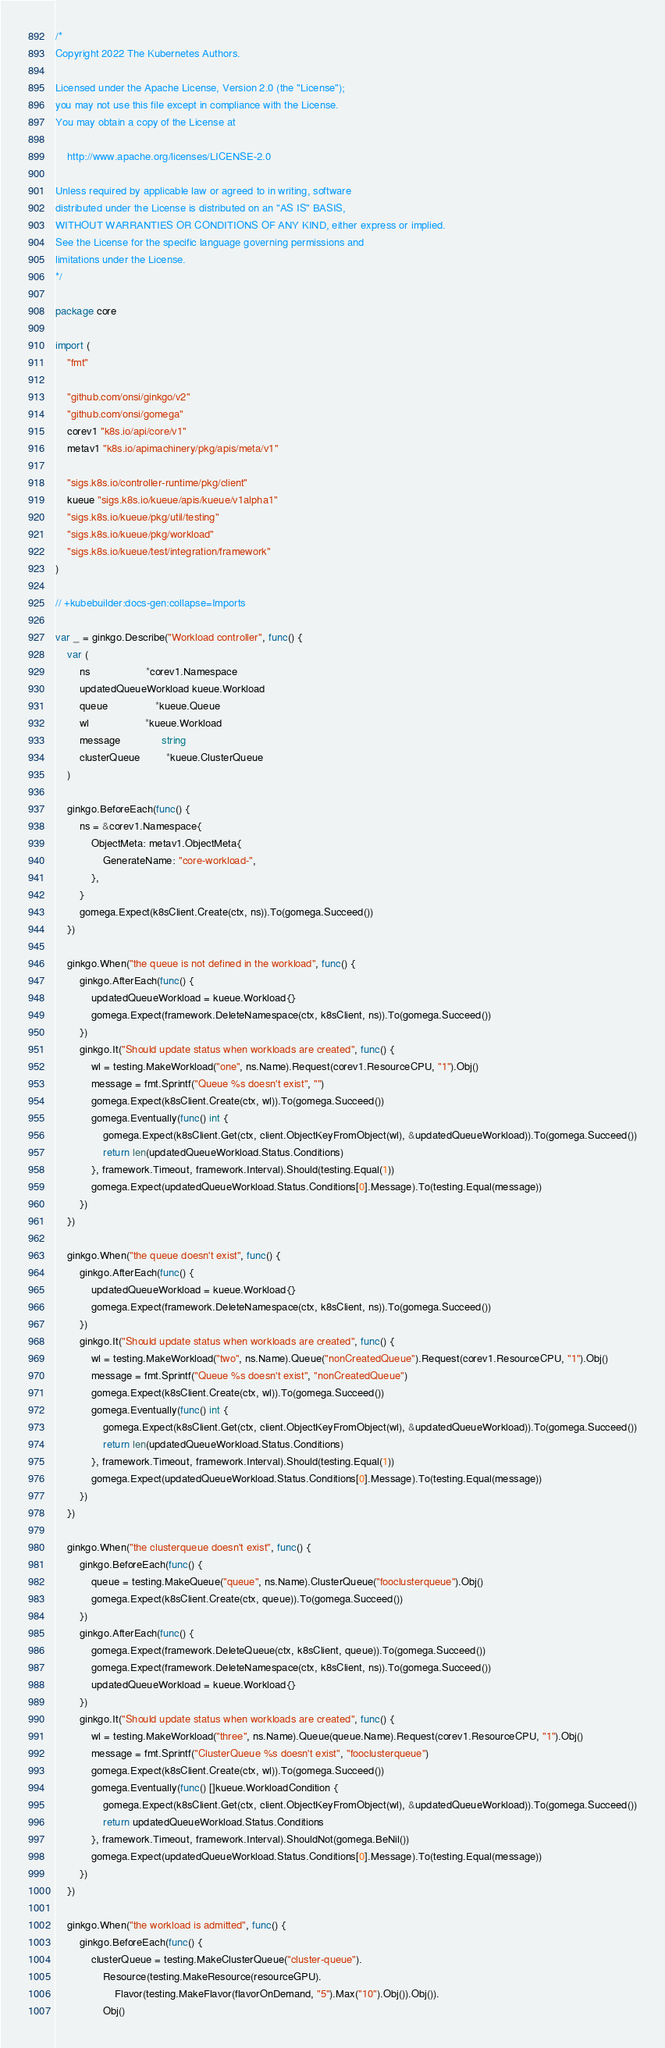<code> <loc_0><loc_0><loc_500><loc_500><_Go_>/*
Copyright 2022 The Kubernetes Authors.

Licensed under the Apache License, Version 2.0 (the "License");
you may not use this file except in compliance with the License.
You may obtain a copy of the License at

    http://www.apache.org/licenses/LICENSE-2.0

Unless required by applicable law or agreed to in writing, software
distributed under the License is distributed on an "AS IS" BASIS,
WITHOUT WARRANTIES OR CONDITIONS OF ANY KIND, either express or implied.
See the License for the specific language governing permissions and
limitations under the License.
*/

package core

import (
	"fmt"

	"github.com/onsi/ginkgo/v2"
	"github.com/onsi/gomega"
	corev1 "k8s.io/api/core/v1"
	metav1 "k8s.io/apimachinery/pkg/apis/meta/v1"

	"sigs.k8s.io/controller-runtime/pkg/client"
	kueue "sigs.k8s.io/kueue/apis/kueue/v1alpha1"
	"sigs.k8s.io/kueue/pkg/util/testing"
	"sigs.k8s.io/kueue/pkg/workload"
	"sigs.k8s.io/kueue/test/integration/framework"
)

// +kubebuilder:docs-gen:collapse=Imports

var _ = ginkgo.Describe("Workload controller", func() {
	var (
		ns                   *corev1.Namespace
		updatedQueueWorkload kueue.Workload
		queue                *kueue.Queue
		wl                   *kueue.Workload
		message              string
		clusterQueue         *kueue.ClusterQueue
	)

	ginkgo.BeforeEach(func() {
		ns = &corev1.Namespace{
			ObjectMeta: metav1.ObjectMeta{
				GenerateName: "core-workload-",
			},
		}
		gomega.Expect(k8sClient.Create(ctx, ns)).To(gomega.Succeed())
	})

	ginkgo.When("the queue is not defined in the workload", func() {
		ginkgo.AfterEach(func() {
			updatedQueueWorkload = kueue.Workload{}
			gomega.Expect(framework.DeleteNamespace(ctx, k8sClient, ns)).To(gomega.Succeed())
		})
		ginkgo.It("Should update status when workloads are created", func() {
			wl = testing.MakeWorkload("one", ns.Name).Request(corev1.ResourceCPU, "1").Obj()
			message = fmt.Sprintf("Queue %s doesn't exist", "")
			gomega.Expect(k8sClient.Create(ctx, wl)).To(gomega.Succeed())
			gomega.Eventually(func() int {
				gomega.Expect(k8sClient.Get(ctx, client.ObjectKeyFromObject(wl), &updatedQueueWorkload)).To(gomega.Succeed())
				return len(updatedQueueWorkload.Status.Conditions)
			}, framework.Timeout, framework.Interval).Should(testing.Equal(1))
			gomega.Expect(updatedQueueWorkload.Status.Conditions[0].Message).To(testing.Equal(message))
		})
	})

	ginkgo.When("the queue doesn't exist", func() {
		ginkgo.AfterEach(func() {
			updatedQueueWorkload = kueue.Workload{}
			gomega.Expect(framework.DeleteNamespace(ctx, k8sClient, ns)).To(gomega.Succeed())
		})
		ginkgo.It("Should update status when workloads are created", func() {
			wl = testing.MakeWorkload("two", ns.Name).Queue("nonCreatedQueue").Request(corev1.ResourceCPU, "1").Obj()
			message = fmt.Sprintf("Queue %s doesn't exist", "nonCreatedQueue")
			gomega.Expect(k8sClient.Create(ctx, wl)).To(gomega.Succeed())
			gomega.Eventually(func() int {
				gomega.Expect(k8sClient.Get(ctx, client.ObjectKeyFromObject(wl), &updatedQueueWorkload)).To(gomega.Succeed())
				return len(updatedQueueWorkload.Status.Conditions)
			}, framework.Timeout, framework.Interval).Should(testing.Equal(1))
			gomega.Expect(updatedQueueWorkload.Status.Conditions[0].Message).To(testing.Equal(message))
		})
	})

	ginkgo.When("the clusterqueue doesn't exist", func() {
		ginkgo.BeforeEach(func() {
			queue = testing.MakeQueue("queue", ns.Name).ClusterQueue("fooclusterqueue").Obj()
			gomega.Expect(k8sClient.Create(ctx, queue)).To(gomega.Succeed())
		})
		ginkgo.AfterEach(func() {
			gomega.Expect(framework.DeleteQueue(ctx, k8sClient, queue)).To(gomega.Succeed())
			gomega.Expect(framework.DeleteNamespace(ctx, k8sClient, ns)).To(gomega.Succeed())
			updatedQueueWorkload = kueue.Workload{}
		})
		ginkgo.It("Should update status when workloads are created", func() {
			wl = testing.MakeWorkload("three", ns.Name).Queue(queue.Name).Request(corev1.ResourceCPU, "1").Obj()
			message = fmt.Sprintf("ClusterQueue %s doesn't exist", "fooclusterqueue")
			gomega.Expect(k8sClient.Create(ctx, wl)).To(gomega.Succeed())
			gomega.Eventually(func() []kueue.WorkloadCondition {
				gomega.Expect(k8sClient.Get(ctx, client.ObjectKeyFromObject(wl), &updatedQueueWorkload)).To(gomega.Succeed())
				return updatedQueueWorkload.Status.Conditions
			}, framework.Timeout, framework.Interval).ShouldNot(gomega.BeNil())
			gomega.Expect(updatedQueueWorkload.Status.Conditions[0].Message).To(testing.Equal(message))
		})
	})

	ginkgo.When("the workload is admitted", func() {
		ginkgo.BeforeEach(func() {
			clusterQueue = testing.MakeClusterQueue("cluster-queue").
				Resource(testing.MakeResource(resourceGPU).
					Flavor(testing.MakeFlavor(flavorOnDemand, "5").Max("10").Obj()).Obj()).
				Obj()</code> 